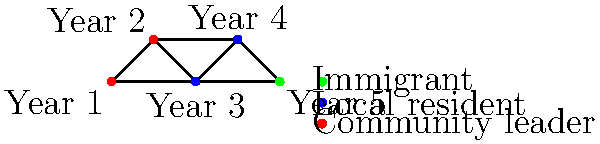In the social network graph showing the integration of immigrants in a community over five years, what is the minimum number of connections an immigrant needs to establish with local residents to reach a community leader? To answer this question, we need to analyze the graph and follow these steps:

1. Identify the nodes:
   - Green node (Year 5): Immigrant
   - Blue nodes (Years 3 and 4): Local residents
   - Red nodes (Years 1 and 2): Community leaders

2. Find the shortest path from the immigrant to a community leader:
   - The immigrant (green node) is directly connected to a local resident (blue node) in Year 4.
   - The local resident in Year 4 is directly connected to a community leader (red node) in Year 2.

3. Count the connections:
   - Connection 1: Immigrant to local resident
   - Connection 2: Local resident to community leader

Therefore, the minimum number of connections an immigrant needs to establish with local residents to reach a community leader is 2.
Answer: 2 connections 